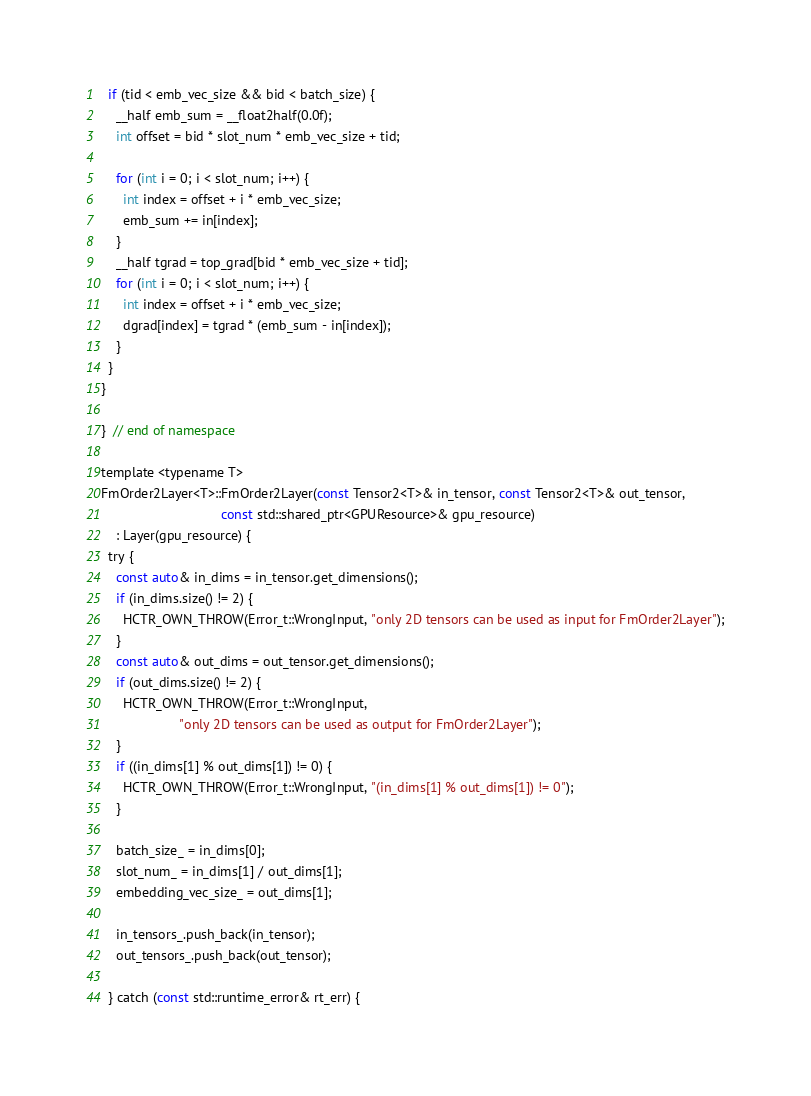Convert code to text. <code><loc_0><loc_0><loc_500><loc_500><_Cuda_>
  if (tid < emb_vec_size && bid < batch_size) {
    __half emb_sum = __float2half(0.0f);
    int offset = bid * slot_num * emb_vec_size + tid;

    for (int i = 0; i < slot_num; i++) {
      int index = offset + i * emb_vec_size;
      emb_sum += in[index];
    }
    __half tgrad = top_grad[bid * emb_vec_size + tid];
    for (int i = 0; i < slot_num; i++) {
      int index = offset + i * emb_vec_size;
      dgrad[index] = tgrad * (emb_sum - in[index]);
    }
  }
}

}  // end of namespace

template <typename T>
FmOrder2Layer<T>::FmOrder2Layer(const Tensor2<T>& in_tensor, const Tensor2<T>& out_tensor,
                                const std::shared_ptr<GPUResource>& gpu_resource)
    : Layer(gpu_resource) {
  try {
    const auto& in_dims = in_tensor.get_dimensions();
    if (in_dims.size() != 2) {
      HCTR_OWN_THROW(Error_t::WrongInput, "only 2D tensors can be used as input for FmOrder2Layer");
    }
    const auto& out_dims = out_tensor.get_dimensions();
    if (out_dims.size() != 2) {
      HCTR_OWN_THROW(Error_t::WrongInput,
                     "only 2D tensors can be used as output for FmOrder2Layer");
    }
    if ((in_dims[1] % out_dims[1]) != 0) {
      HCTR_OWN_THROW(Error_t::WrongInput, "(in_dims[1] % out_dims[1]) != 0");
    }

    batch_size_ = in_dims[0];
    slot_num_ = in_dims[1] / out_dims[1];
    embedding_vec_size_ = out_dims[1];

    in_tensors_.push_back(in_tensor);
    out_tensors_.push_back(out_tensor);

  } catch (const std::runtime_error& rt_err) {</code> 